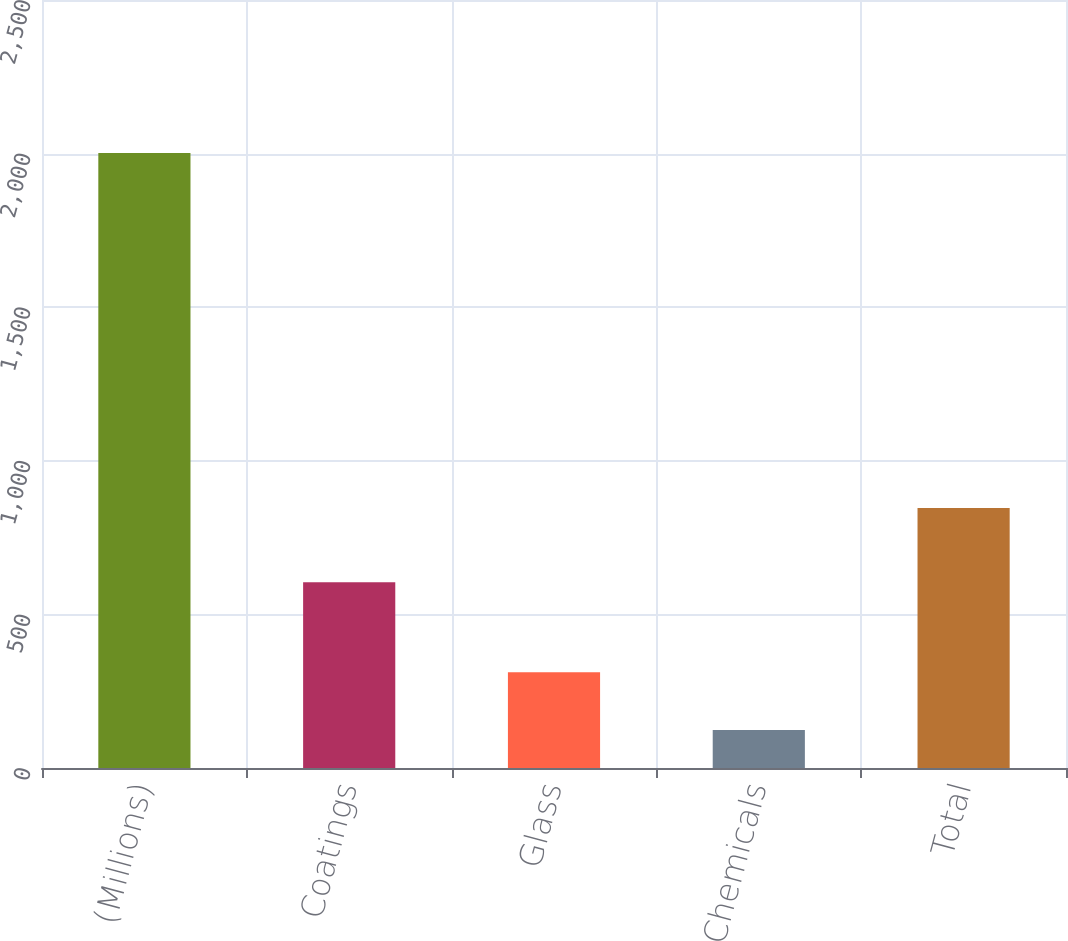<chart> <loc_0><loc_0><loc_500><loc_500><bar_chart><fcel>(Millions)<fcel>Coatings<fcel>Glass<fcel>Chemicals<fcel>Total<nl><fcel>2002<fcel>605<fcel>311.8<fcel>124<fcel>846<nl></chart> 